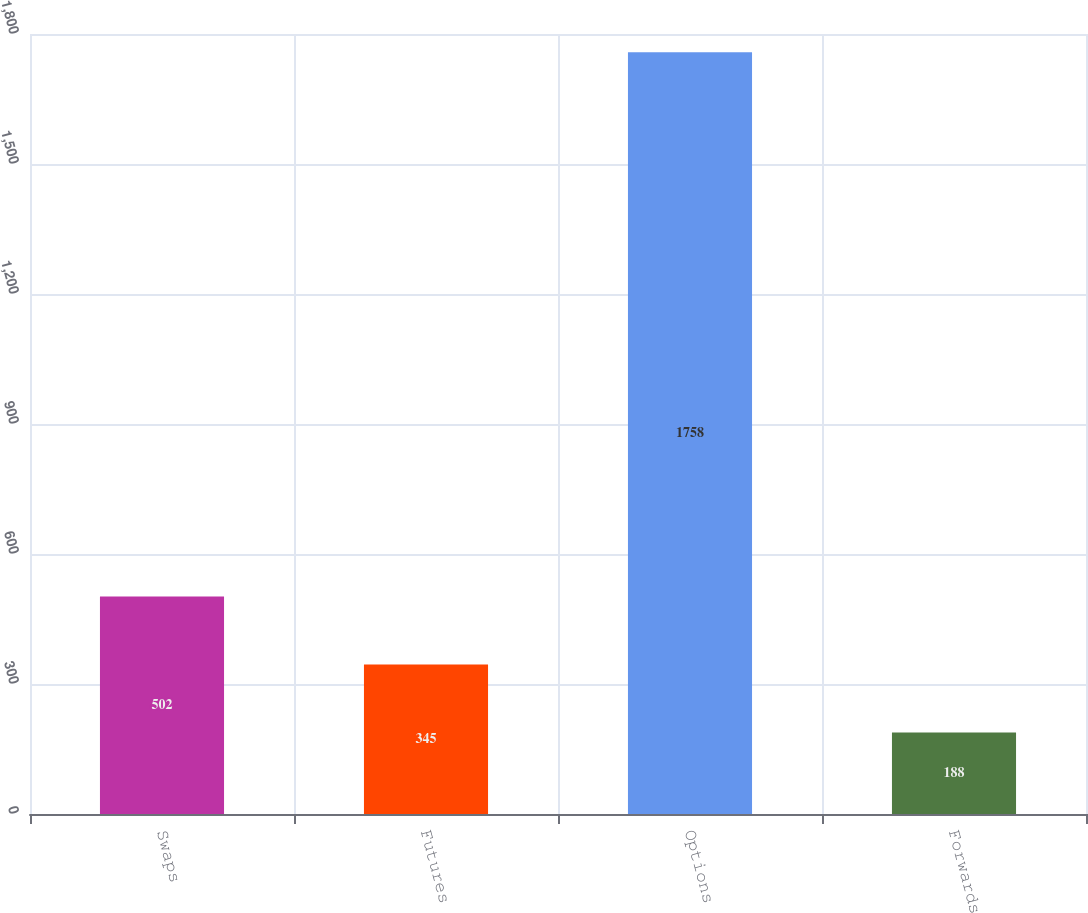<chart> <loc_0><loc_0><loc_500><loc_500><bar_chart><fcel>Swaps<fcel>Futures<fcel>Options<fcel>Forwards<nl><fcel>502<fcel>345<fcel>1758<fcel>188<nl></chart> 